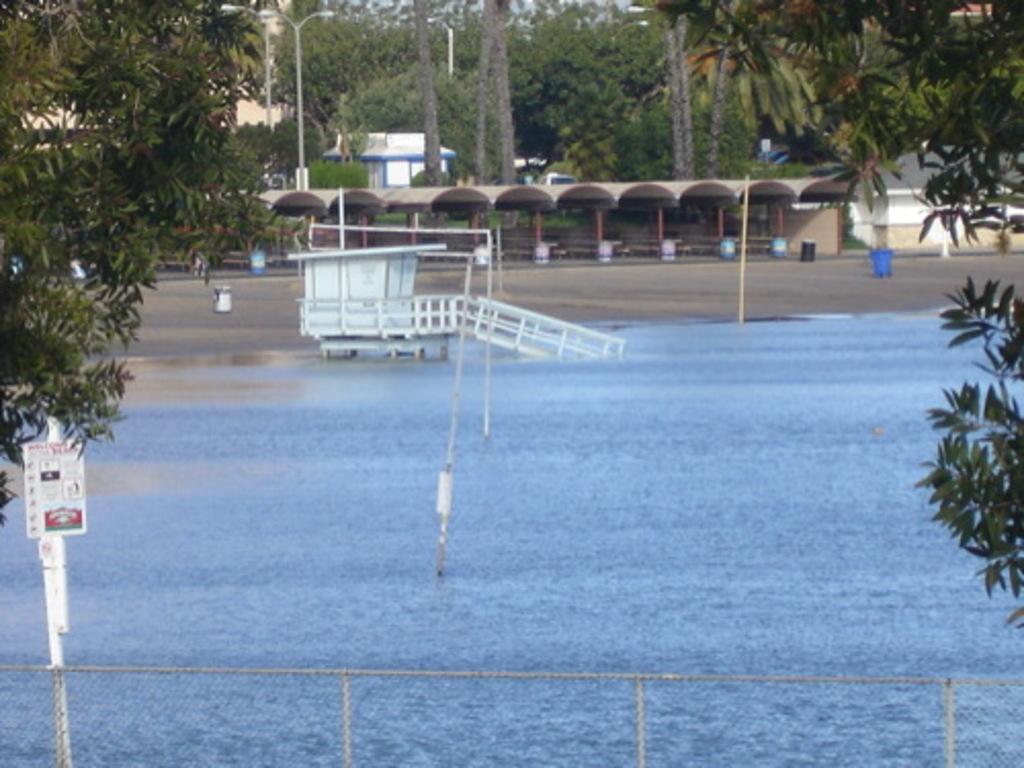Describe this image in one or two sentences. In this picture we can see the water, fence, trees, poles, shelters and some objects. 